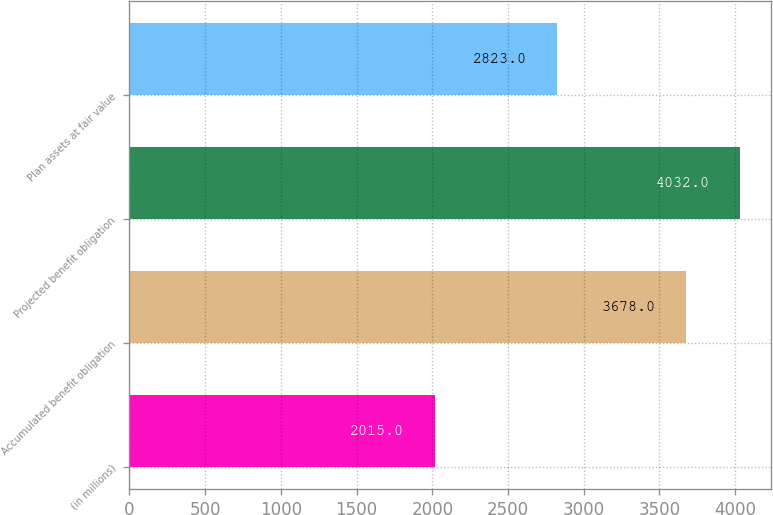<chart> <loc_0><loc_0><loc_500><loc_500><bar_chart><fcel>(in millions)<fcel>Accumulated benefit obligation<fcel>Projected benefit obligation<fcel>Plan assets at fair value<nl><fcel>2015<fcel>3678<fcel>4032<fcel>2823<nl></chart> 